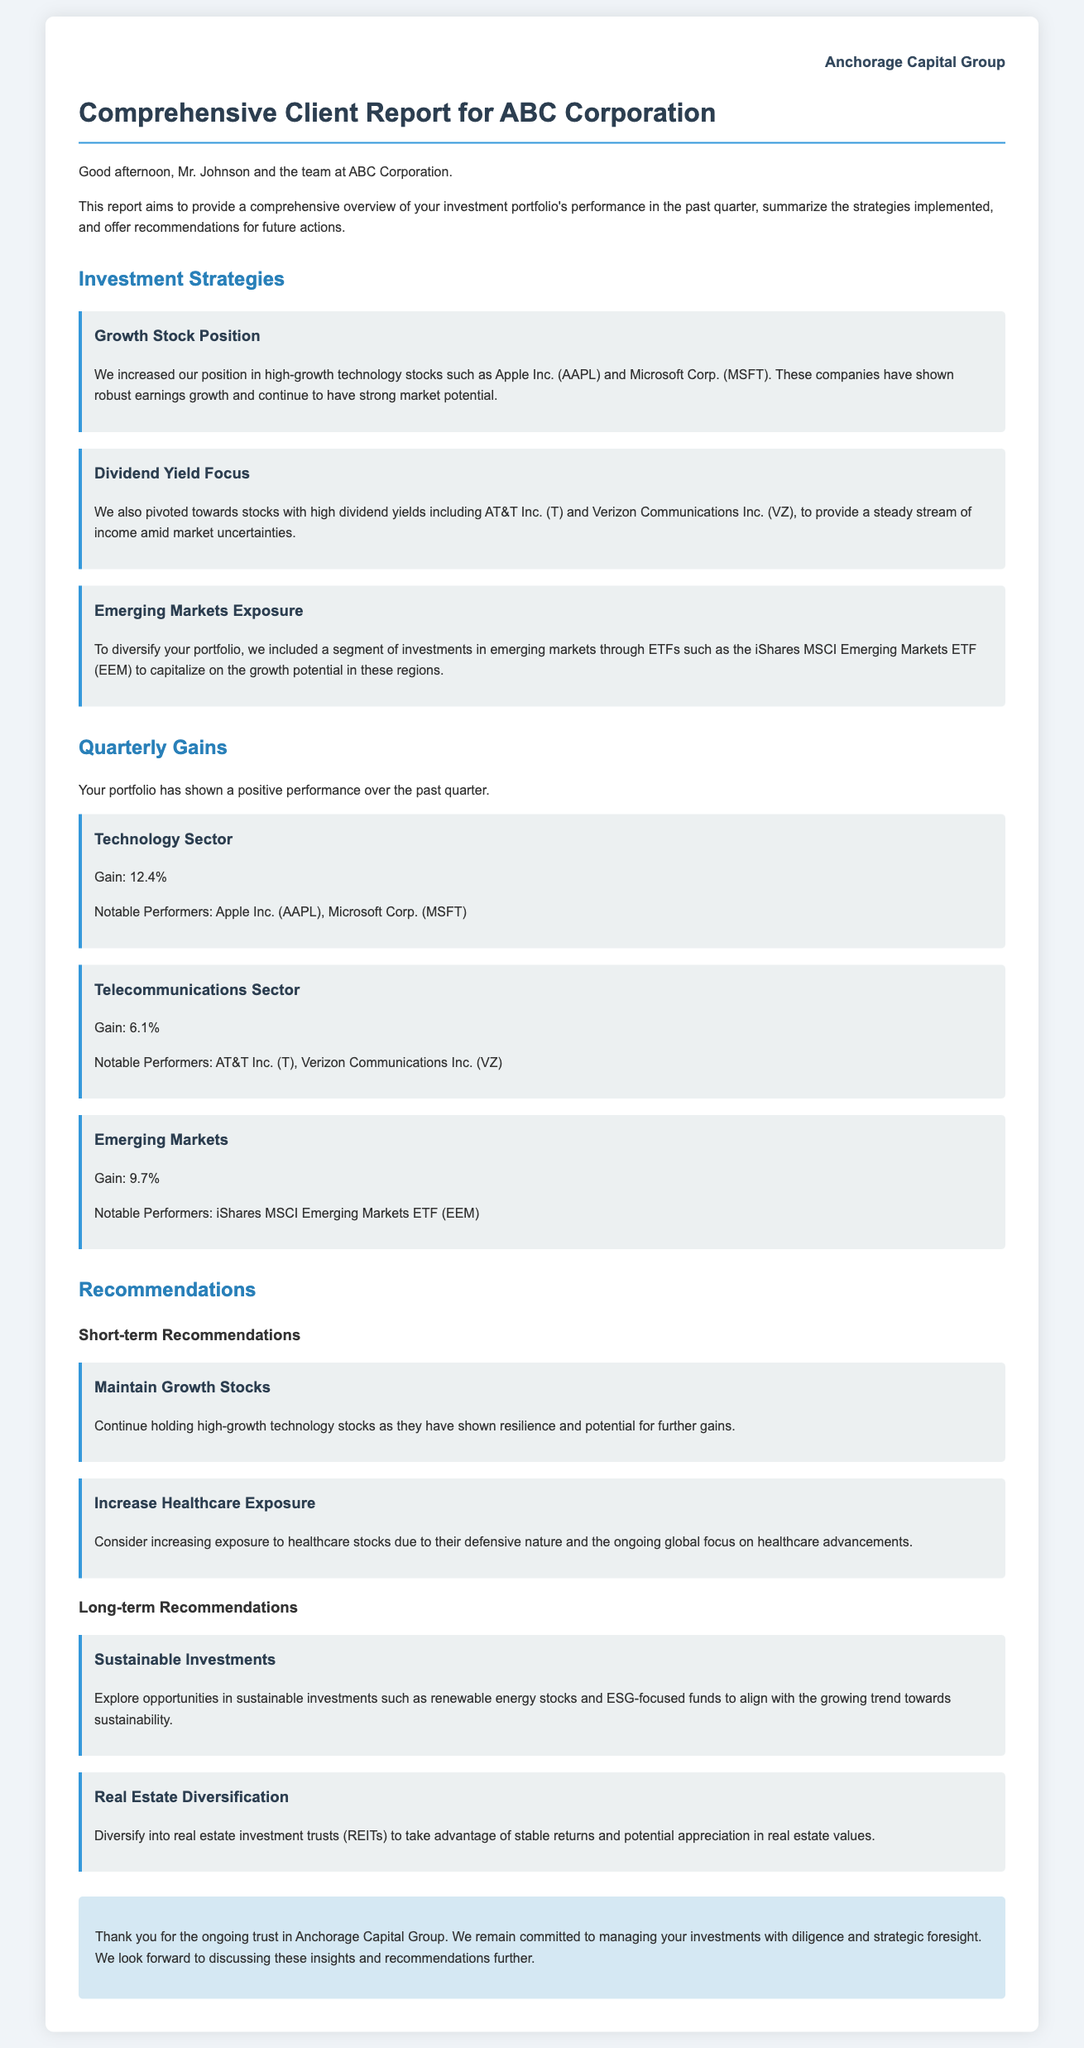What is the title of the document? The title of the document is found in the HTML header and indicates the purpose of the report.
Answer: Comprehensive Client Report for ABC Corporation Who is the report addressed to? The introduction of the report specifies the recipient by name.
Answer: Mr. Johnson and the team at ABC Corporation What was the gain in the Technology Sector? The quarterly gains section provides specific percentage gains for each sector.
Answer: 12.4% Which company is mentioned as part of the Dividend Yield Focus strategy? This information is included under the investment strategies section, detailing specific companies.
Answer: AT&T Inc What type of investments are recommended for long-term strategies? The recommendations section outlines specific focus areas for long-term investments.
Answer: Sustainable Investments What is one of the notable performers in the Telecommunications Sector? Notable performers are listed under the quarterly gains section for different sectors.
Answer: AT&T Inc How should clients approach Growth Stocks according to the short-term recommendations? This recommendation is stated explicitly in the recommendations section regarding growth stocks.
Answer: Continue holding Which emerging markets ETF was mentioned in the investment strategies? The investment strategies section explicitly names the ETF included for diversification.
Answer: iShares MSCI Emerging Markets ETF What is the gain for the Emerging Markets? The specific percentage gain for the Emerging Markets is provided in the quarterly gains section.
Answer: 9.7% 